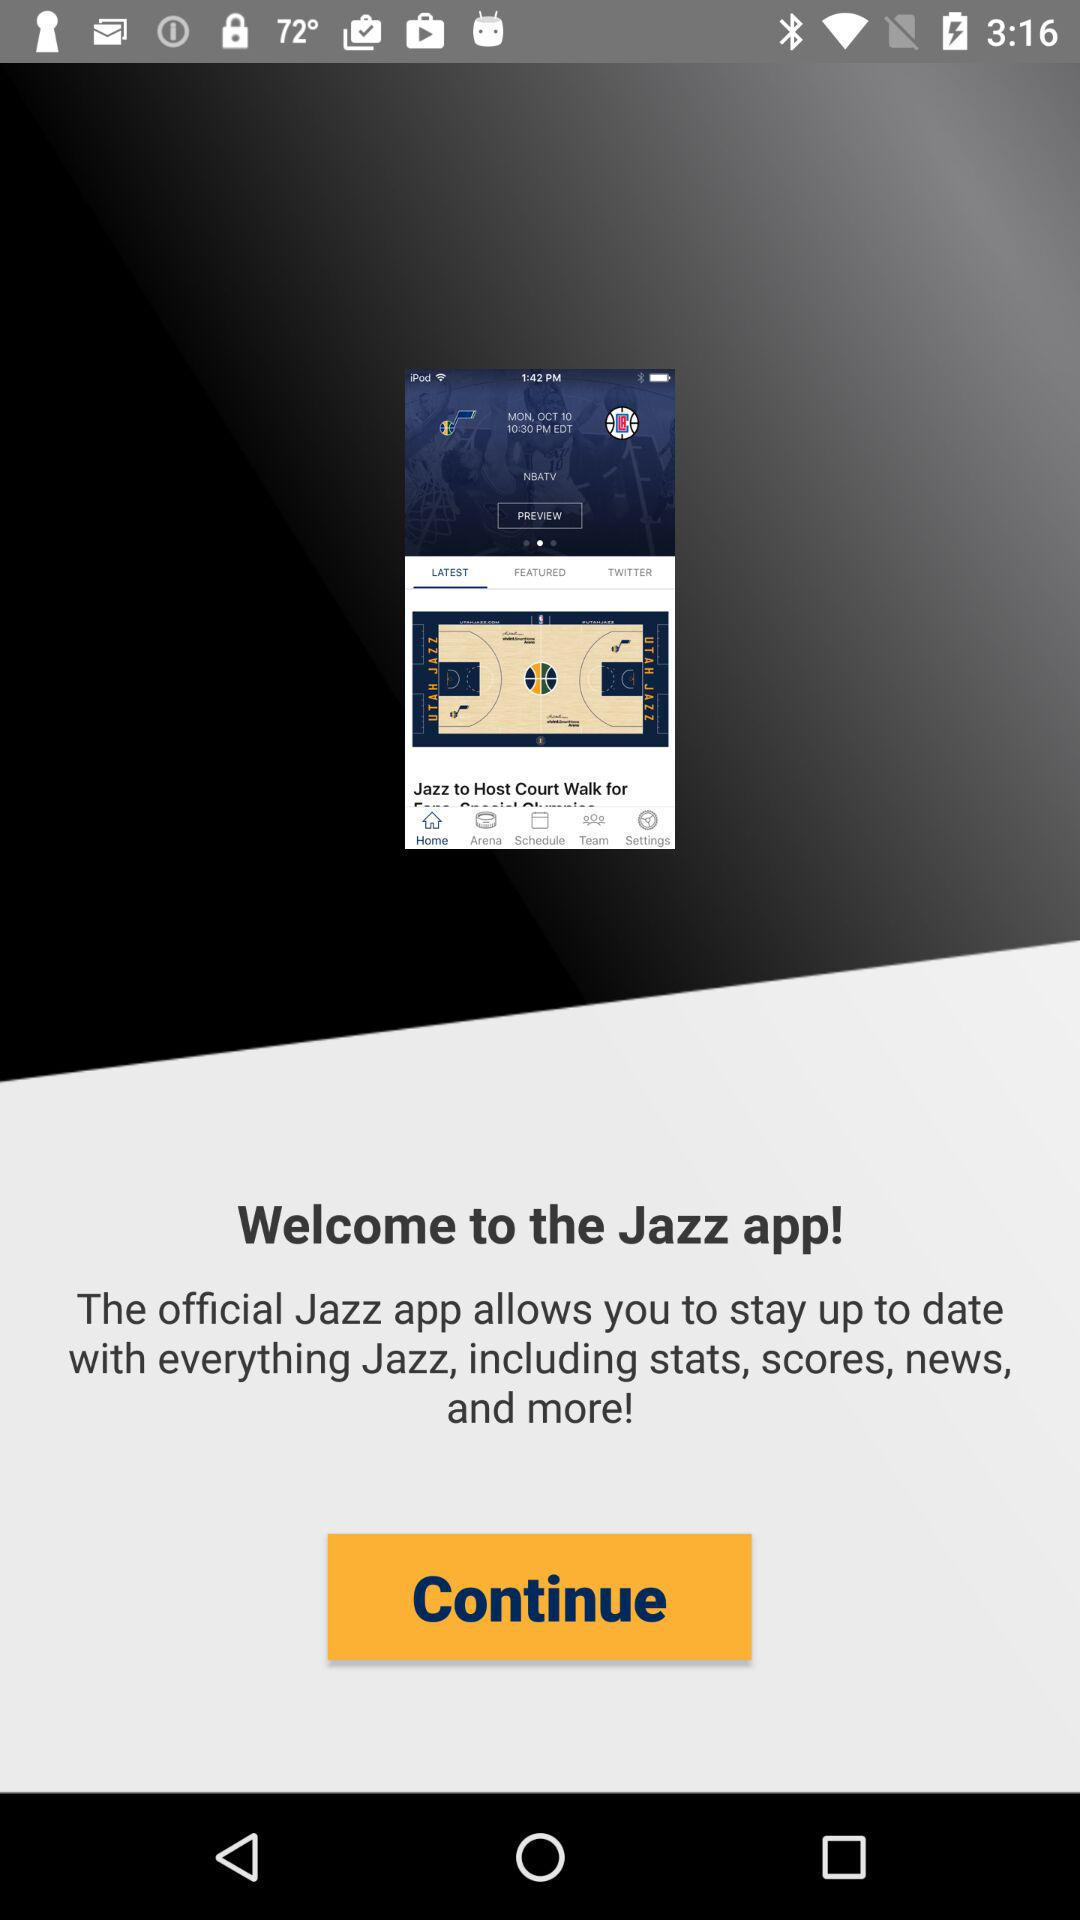What is the name of the application? The name of the application is "Jazz". 